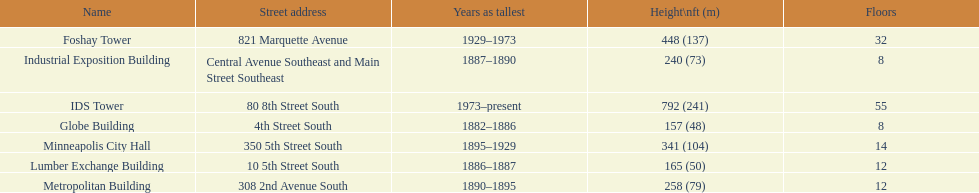Name the tallest building. IDS Tower. 